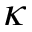<formula> <loc_0><loc_0><loc_500><loc_500>\kappa</formula> 